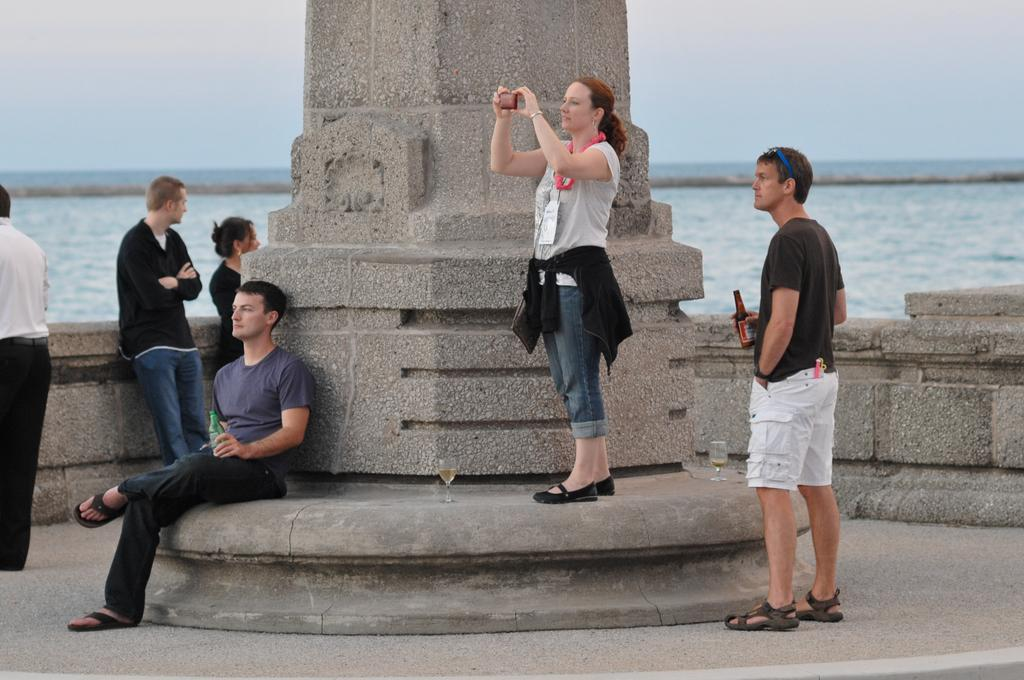What is the main structure in the image? There is a pillar in the image. Who is present in the image? There are people in the image. What objects can be seen in the image? There are glasses, a mobile, and bottles visible in the image. What is the woman in the image wearing? The woman is wearing a bag. What can be seen in the background of the image? The sky and water are visible in the background of the image. How many leaves are on the ground in the image? There are no leaves visible in the image; it does not show a ground or any leaves. 